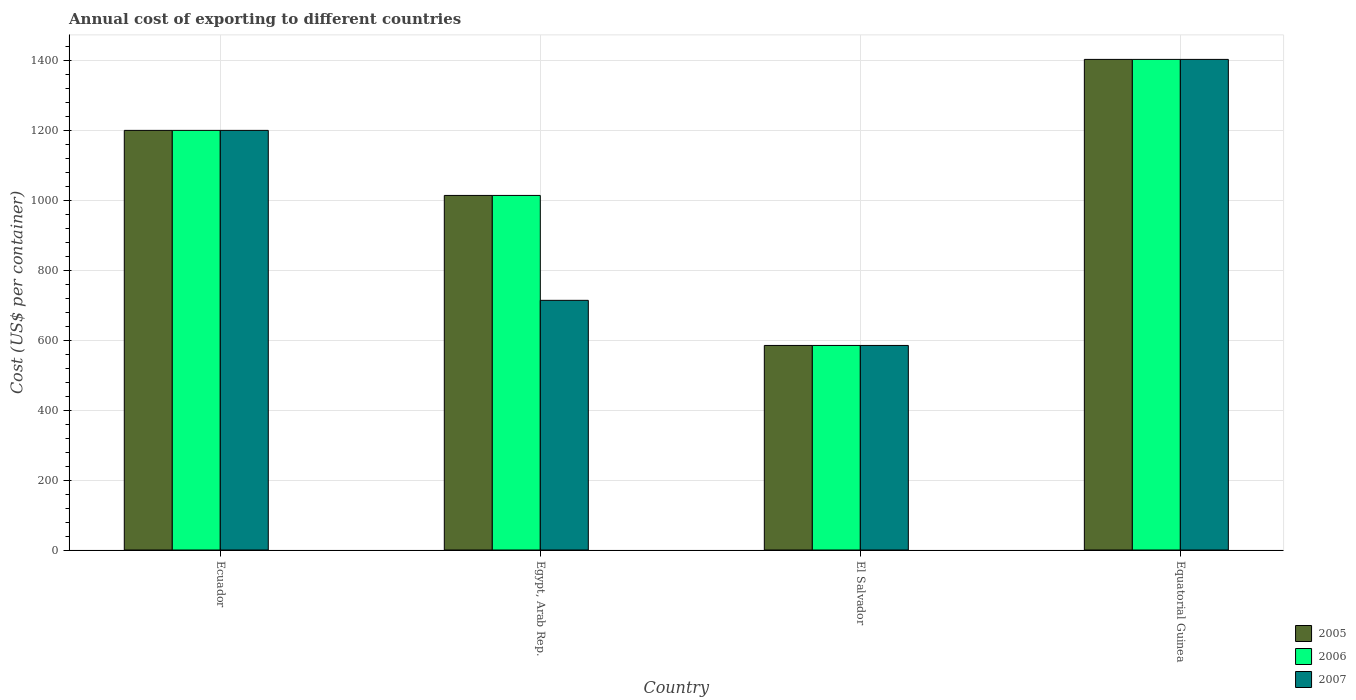Are the number of bars per tick equal to the number of legend labels?
Provide a short and direct response. Yes. Are the number of bars on each tick of the X-axis equal?
Provide a short and direct response. Yes. How many bars are there on the 1st tick from the left?
Give a very brief answer. 3. What is the label of the 2nd group of bars from the left?
Provide a short and direct response. Egypt, Arab Rep. In how many cases, is the number of bars for a given country not equal to the number of legend labels?
Make the answer very short. 0. What is the total annual cost of exporting in 2006 in El Salvador?
Offer a very short reply. 585. Across all countries, what is the maximum total annual cost of exporting in 2007?
Ensure brevity in your answer.  1403. Across all countries, what is the minimum total annual cost of exporting in 2007?
Make the answer very short. 585. In which country was the total annual cost of exporting in 2005 maximum?
Give a very brief answer. Equatorial Guinea. In which country was the total annual cost of exporting in 2006 minimum?
Offer a terse response. El Salvador. What is the total total annual cost of exporting in 2006 in the graph?
Your response must be concise. 4202. What is the difference between the total annual cost of exporting in 2007 in Ecuador and that in El Salvador?
Your response must be concise. 615. What is the difference between the total annual cost of exporting in 2007 in Ecuador and the total annual cost of exporting in 2005 in Egypt, Arab Rep.?
Ensure brevity in your answer.  186. What is the average total annual cost of exporting in 2007 per country?
Your answer should be compact. 975.5. What is the difference between the total annual cost of exporting of/in 2007 and total annual cost of exporting of/in 2006 in El Salvador?
Ensure brevity in your answer.  0. In how many countries, is the total annual cost of exporting in 2006 greater than 80 US$?
Your answer should be compact. 4. What is the ratio of the total annual cost of exporting in 2005 in Ecuador to that in Equatorial Guinea?
Offer a very short reply. 0.86. What is the difference between the highest and the second highest total annual cost of exporting in 2007?
Your response must be concise. 486. What is the difference between the highest and the lowest total annual cost of exporting in 2006?
Keep it short and to the point. 818. Is the sum of the total annual cost of exporting in 2006 in El Salvador and Equatorial Guinea greater than the maximum total annual cost of exporting in 2005 across all countries?
Provide a succinct answer. Yes. Is it the case that in every country, the sum of the total annual cost of exporting in 2005 and total annual cost of exporting in 2007 is greater than the total annual cost of exporting in 2006?
Provide a short and direct response. Yes. How many bars are there?
Provide a short and direct response. 12. Are all the bars in the graph horizontal?
Keep it short and to the point. No. Are the values on the major ticks of Y-axis written in scientific E-notation?
Make the answer very short. No. Does the graph contain any zero values?
Ensure brevity in your answer.  No. Does the graph contain grids?
Make the answer very short. Yes. What is the title of the graph?
Your response must be concise. Annual cost of exporting to different countries. Does "1989" appear as one of the legend labels in the graph?
Make the answer very short. No. What is the label or title of the Y-axis?
Provide a succinct answer. Cost (US$ per container). What is the Cost (US$ per container) in 2005 in Ecuador?
Provide a succinct answer. 1200. What is the Cost (US$ per container) in 2006 in Ecuador?
Your response must be concise. 1200. What is the Cost (US$ per container) of 2007 in Ecuador?
Your answer should be compact. 1200. What is the Cost (US$ per container) of 2005 in Egypt, Arab Rep.?
Offer a terse response. 1014. What is the Cost (US$ per container) in 2006 in Egypt, Arab Rep.?
Your answer should be very brief. 1014. What is the Cost (US$ per container) in 2007 in Egypt, Arab Rep.?
Offer a very short reply. 714. What is the Cost (US$ per container) of 2005 in El Salvador?
Your response must be concise. 585. What is the Cost (US$ per container) of 2006 in El Salvador?
Offer a very short reply. 585. What is the Cost (US$ per container) of 2007 in El Salvador?
Offer a terse response. 585. What is the Cost (US$ per container) of 2005 in Equatorial Guinea?
Your response must be concise. 1403. What is the Cost (US$ per container) in 2006 in Equatorial Guinea?
Ensure brevity in your answer.  1403. What is the Cost (US$ per container) of 2007 in Equatorial Guinea?
Give a very brief answer. 1403. Across all countries, what is the maximum Cost (US$ per container) of 2005?
Your response must be concise. 1403. Across all countries, what is the maximum Cost (US$ per container) in 2006?
Keep it short and to the point. 1403. Across all countries, what is the maximum Cost (US$ per container) in 2007?
Your answer should be very brief. 1403. Across all countries, what is the minimum Cost (US$ per container) of 2005?
Your response must be concise. 585. Across all countries, what is the minimum Cost (US$ per container) of 2006?
Ensure brevity in your answer.  585. Across all countries, what is the minimum Cost (US$ per container) in 2007?
Your response must be concise. 585. What is the total Cost (US$ per container) in 2005 in the graph?
Ensure brevity in your answer.  4202. What is the total Cost (US$ per container) of 2006 in the graph?
Give a very brief answer. 4202. What is the total Cost (US$ per container) in 2007 in the graph?
Ensure brevity in your answer.  3902. What is the difference between the Cost (US$ per container) of 2005 in Ecuador and that in Egypt, Arab Rep.?
Your answer should be compact. 186. What is the difference between the Cost (US$ per container) of 2006 in Ecuador and that in Egypt, Arab Rep.?
Make the answer very short. 186. What is the difference between the Cost (US$ per container) of 2007 in Ecuador and that in Egypt, Arab Rep.?
Make the answer very short. 486. What is the difference between the Cost (US$ per container) in 2005 in Ecuador and that in El Salvador?
Keep it short and to the point. 615. What is the difference between the Cost (US$ per container) of 2006 in Ecuador and that in El Salvador?
Offer a very short reply. 615. What is the difference between the Cost (US$ per container) in 2007 in Ecuador and that in El Salvador?
Ensure brevity in your answer.  615. What is the difference between the Cost (US$ per container) of 2005 in Ecuador and that in Equatorial Guinea?
Provide a succinct answer. -203. What is the difference between the Cost (US$ per container) in 2006 in Ecuador and that in Equatorial Guinea?
Your answer should be compact. -203. What is the difference between the Cost (US$ per container) of 2007 in Ecuador and that in Equatorial Guinea?
Give a very brief answer. -203. What is the difference between the Cost (US$ per container) of 2005 in Egypt, Arab Rep. and that in El Salvador?
Make the answer very short. 429. What is the difference between the Cost (US$ per container) of 2006 in Egypt, Arab Rep. and that in El Salvador?
Offer a very short reply. 429. What is the difference between the Cost (US$ per container) of 2007 in Egypt, Arab Rep. and that in El Salvador?
Ensure brevity in your answer.  129. What is the difference between the Cost (US$ per container) in 2005 in Egypt, Arab Rep. and that in Equatorial Guinea?
Provide a succinct answer. -389. What is the difference between the Cost (US$ per container) of 2006 in Egypt, Arab Rep. and that in Equatorial Guinea?
Offer a very short reply. -389. What is the difference between the Cost (US$ per container) of 2007 in Egypt, Arab Rep. and that in Equatorial Guinea?
Ensure brevity in your answer.  -689. What is the difference between the Cost (US$ per container) in 2005 in El Salvador and that in Equatorial Guinea?
Your answer should be compact. -818. What is the difference between the Cost (US$ per container) of 2006 in El Salvador and that in Equatorial Guinea?
Provide a succinct answer. -818. What is the difference between the Cost (US$ per container) in 2007 in El Salvador and that in Equatorial Guinea?
Your response must be concise. -818. What is the difference between the Cost (US$ per container) in 2005 in Ecuador and the Cost (US$ per container) in 2006 in Egypt, Arab Rep.?
Keep it short and to the point. 186. What is the difference between the Cost (US$ per container) in 2005 in Ecuador and the Cost (US$ per container) in 2007 in Egypt, Arab Rep.?
Keep it short and to the point. 486. What is the difference between the Cost (US$ per container) in 2006 in Ecuador and the Cost (US$ per container) in 2007 in Egypt, Arab Rep.?
Your response must be concise. 486. What is the difference between the Cost (US$ per container) in 2005 in Ecuador and the Cost (US$ per container) in 2006 in El Salvador?
Give a very brief answer. 615. What is the difference between the Cost (US$ per container) of 2005 in Ecuador and the Cost (US$ per container) of 2007 in El Salvador?
Your answer should be very brief. 615. What is the difference between the Cost (US$ per container) in 2006 in Ecuador and the Cost (US$ per container) in 2007 in El Salvador?
Your answer should be very brief. 615. What is the difference between the Cost (US$ per container) in 2005 in Ecuador and the Cost (US$ per container) in 2006 in Equatorial Guinea?
Your answer should be compact. -203. What is the difference between the Cost (US$ per container) of 2005 in Ecuador and the Cost (US$ per container) of 2007 in Equatorial Guinea?
Offer a terse response. -203. What is the difference between the Cost (US$ per container) of 2006 in Ecuador and the Cost (US$ per container) of 2007 in Equatorial Guinea?
Offer a terse response. -203. What is the difference between the Cost (US$ per container) in 2005 in Egypt, Arab Rep. and the Cost (US$ per container) in 2006 in El Salvador?
Offer a very short reply. 429. What is the difference between the Cost (US$ per container) in 2005 in Egypt, Arab Rep. and the Cost (US$ per container) in 2007 in El Salvador?
Your answer should be compact. 429. What is the difference between the Cost (US$ per container) of 2006 in Egypt, Arab Rep. and the Cost (US$ per container) of 2007 in El Salvador?
Make the answer very short. 429. What is the difference between the Cost (US$ per container) in 2005 in Egypt, Arab Rep. and the Cost (US$ per container) in 2006 in Equatorial Guinea?
Offer a very short reply. -389. What is the difference between the Cost (US$ per container) of 2005 in Egypt, Arab Rep. and the Cost (US$ per container) of 2007 in Equatorial Guinea?
Your response must be concise. -389. What is the difference between the Cost (US$ per container) of 2006 in Egypt, Arab Rep. and the Cost (US$ per container) of 2007 in Equatorial Guinea?
Offer a terse response. -389. What is the difference between the Cost (US$ per container) in 2005 in El Salvador and the Cost (US$ per container) in 2006 in Equatorial Guinea?
Your answer should be very brief. -818. What is the difference between the Cost (US$ per container) in 2005 in El Salvador and the Cost (US$ per container) in 2007 in Equatorial Guinea?
Make the answer very short. -818. What is the difference between the Cost (US$ per container) in 2006 in El Salvador and the Cost (US$ per container) in 2007 in Equatorial Guinea?
Offer a terse response. -818. What is the average Cost (US$ per container) in 2005 per country?
Offer a very short reply. 1050.5. What is the average Cost (US$ per container) of 2006 per country?
Keep it short and to the point. 1050.5. What is the average Cost (US$ per container) of 2007 per country?
Offer a very short reply. 975.5. What is the difference between the Cost (US$ per container) in 2005 and Cost (US$ per container) in 2007 in Ecuador?
Give a very brief answer. 0. What is the difference between the Cost (US$ per container) of 2005 and Cost (US$ per container) of 2006 in Egypt, Arab Rep.?
Your response must be concise. 0. What is the difference between the Cost (US$ per container) of 2005 and Cost (US$ per container) of 2007 in Egypt, Arab Rep.?
Make the answer very short. 300. What is the difference between the Cost (US$ per container) in 2006 and Cost (US$ per container) in 2007 in Egypt, Arab Rep.?
Your response must be concise. 300. What is the difference between the Cost (US$ per container) in 2005 and Cost (US$ per container) in 2006 in El Salvador?
Keep it short and to the point. 0. What is the difference between the Cost (US$ per container) of 2006 and Cost (US$ per container) of 2007 in Equatorial Guinea?
Offer a very short reply. 0. What is the ratio of the Cost (US$ per container) in 2005 in Ecuador to that in Egypt, Arab Rep.?
Keep it short and to the point. 1.18. What is the ratio of the Cost (US$ per container) in 2006 in Ecuador to that in Egypt, Arab Rep.?
Keep it short and to the point. 1.18. What is the ratio of the Cost (US$ per container) in 2007 in Ecuador to that in Egypt, Arab Rep.?
Your response must be concise. 1.68. What is the ratio of the Cost (US$ per container) in 2005 in Ecuador to that in El Salvador?
Offer a terse response. 2.05. What is the ratio of the Cost (US$ per container) of 2006 in Ecuador to that in El Salvador?
Provide a short and direct response. 2.05. What is the ratio of the Cost (US$ per container) in 2007 in Ecuador to that in El Salvador?
Keep it short and to the point. 2.05. What is the ratio of the Cost (US$ per container) in 2005 in Ecuador to that in Equatorial Guinea?
Provide a short and direct response. 0.86. What is the ratio of the Cost (US$ per container) of 2006 in Ecuador to that in Equatorial Guinea?
Give a very brief answer. 0.86. What is the ratio of the Cost (US$ per container) of 2007 in Ecuador to that in Equatorial Guinea?
Provide a succinct answer. 0.86. What is the ratio of the Cost (US$ per container) in 2005 in Egypt, Arab Rep. to that in El Salvador?
Provide a short and direct response. 1.73. What is the ratio of the Cost (US$ per container) of 2006 in Egypt, Arab Rep. to that in El Salvador?
Provide a short and direct response. 1.73. What is the ratio of the Cost (US$ per container) of 2007 in Egypt, Arab Rep. to that in El Salvador?
Make the answer very short. 1.22. What is the ratio of the Cost (US$ per container) of 2005 in Egypt, Arab Rep. to that in Equatorial Guinea?
Your answer should be compact. 0.72. What is the ratio of the Cost (US$ per container) of 2006 in Egypt, Arab Rep. to that in Equatorial Guinea?
Offer a terse response. 0.72. What is the ratio of the Cost (US$ per container) in 2007 in Egypt, Arab Rep. to that in Equatorial Guinea?
Offer a very short reply. 0.51. What is the ratio of the Cost (US$ per container) in 2005 in El Salvador to that in Equatorial Guinea?
Make the answer very short. 0.42. What is the ratio of the Cost (US$ per container) of 2006 in El Salvador to that in Equatorial Guinea?
Your answer should be very brief. 0.42. What is the ratio of the Cost (US$ per container) of 2007 in El Salvador to that in Equatorial Guinea?
Your answer should be compact. 0.42. What is the difference between the highest and the second highest Cost (US$ per container) in 2005?
Your answer should be compact. 203. What is the difference between the highest and the second highest Cost (US$ per container) of 2006?
Your response must be concise. 203. What is the difference between the highest and the second highest Cost (US$ per container) of 2007?
Keep it short and to the point. 203. What is the difference between the highest and the lowest Cost (US$ per container) in 2005?
Provide a short and direct response. 818. What is the difference between the highest and the lowest Cost (US$ per container) of 2006?
Offer a terse response. 818. What is the difference between the highest and the lowest Cost (US$ per container) in 2007?
Ensure brevity in your answer.  818. 